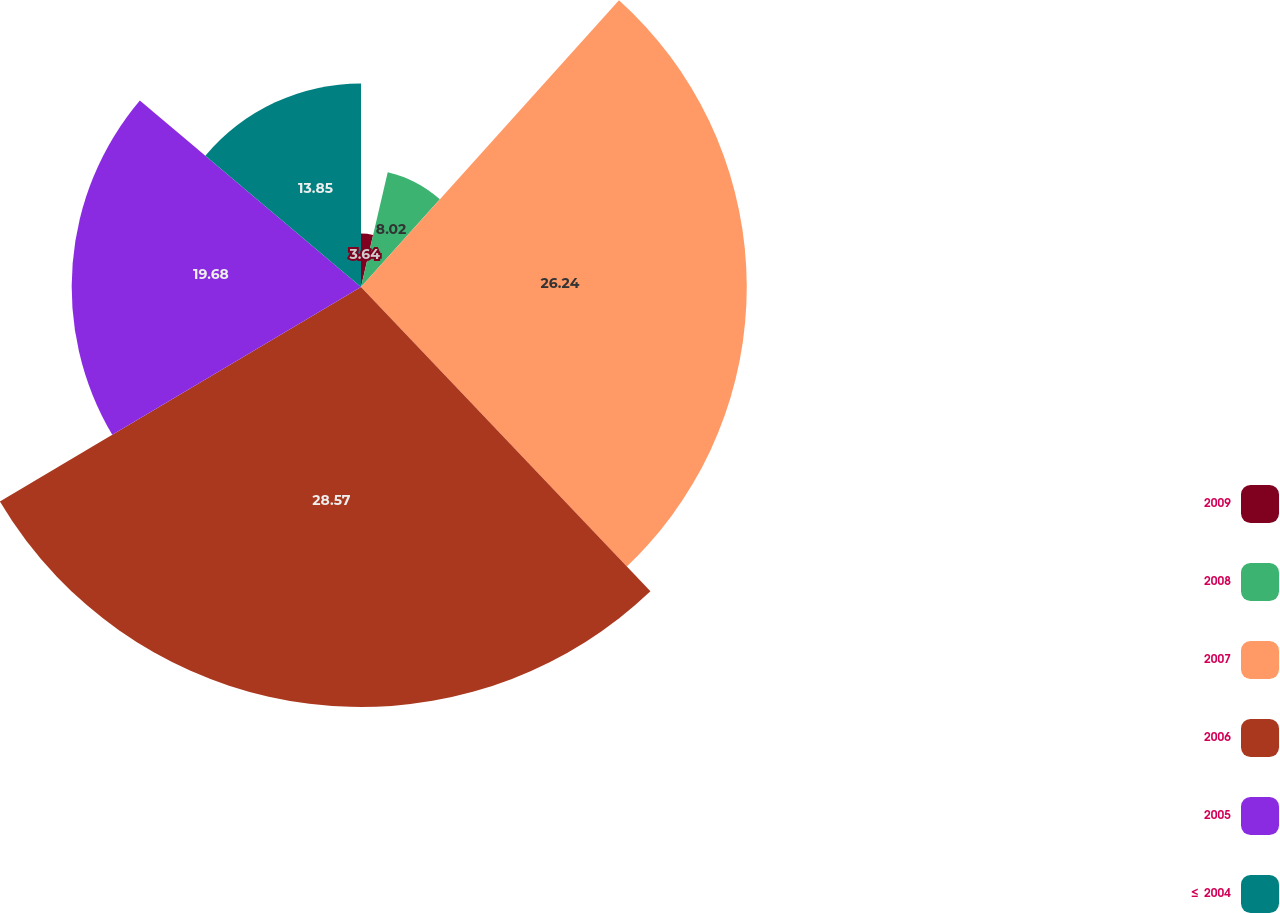<chart> <loc_0><loc_0><loc_500><loc_500><pie_chart><fcel>2009<fcel>2008<fcel>2007<fcel>2006<fcel>2005<fcel>≤ 2004<nl><fcel>3.64%<fcel>8.02%<fcel>26.24%<fcel>28.57%<fcel>19.68%<fcel>13.85%<nl></chart> 